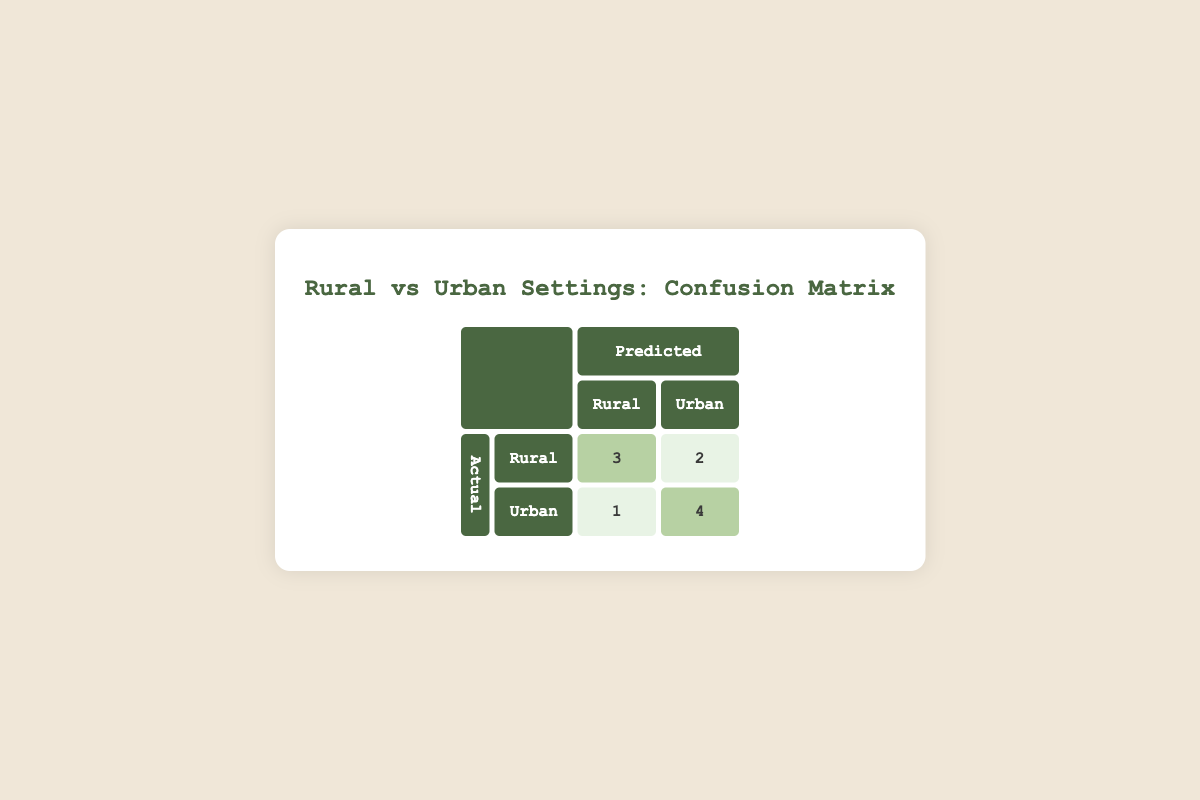What is the number of essays correctly predicted as Rural? The table indicates that the actual count of essays that are Rural and were also predicted as Rural is 3 (found in the cell under the intersection of Actual Rural and Predicted Rural).
Answer: 3 What is the number of essays that were incorrectly predicted as Urban from the Rural category? Referring to the table, there is 1 essay that is actually Rural but was predicted as Urban (found in the cell under the intersection of Actual Rural and Predicted Urban).
Answer: 1 What is the total number of essays categorized as Urban? To find this, we sum the counts of both correctly and incorrectly predicted Urban essays: 1 (Rural predicted as Urban) + 5 (Urban predicted as Urban) = 6.
Answer: 6 How many essays were predicted as Rural overall? By examining the predictions in the table, there are 3 essays predicted as Rural from the Rural category and 3 from the Urban (4 essays in total). We get this by adding the two counts in the 'Rural' column.
Answer: 4 Is it true that more Urban essays were correctly predicted than Rural essays? Yes, the count of Urban essays that were predicted correctly is 5, while only 3 Rural essays were predicted correctly. Thus, it is true.
Answer: Yes What is the difference between the number of predicted Urban essays and the number of actual Rural essays? The total predicted Urban essays (6) minus the actual Rural essays (5) gives us a difference of 1 (6 - 5 = 1).
Answer: 1 How many essays in total were analyzed? The total number of essays is simply the sum of all entries in the confusion matrix: 3 (Rural, Rural) + 1 (Rural, Urban) + 1 (Urban, Rural) + 5 (Urban, Urban) = 10.
Answer: 10 What percentage of the total essays submitted were predicted as Urban? To calculate this percentage, we take the number of predicted Urban essays (6) and divide it by the total number of essays analyzed (10), then multiply by 100. So, (6/10) * 100 = 60%.
Answer: 60% 